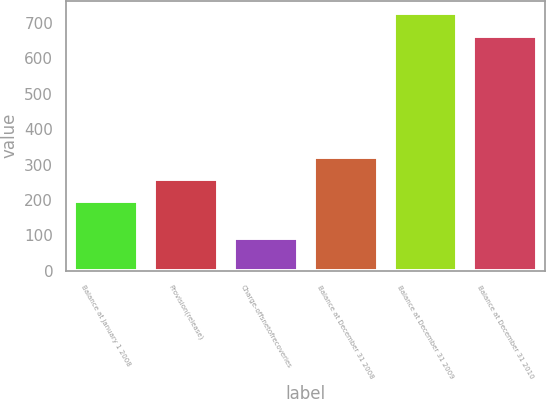Convert chart. <chart><loc_0><loc_0><loc_500><loc_500><bar_chart><fcel>Balance at January 1 2008<fcel>Provision(release)<fcel>Charge-offsnetofrecoveries<fcel>Balance at December 31 2008<fcel>Balance at December 31 2009<fcel>Balance at December 31 2010<nl><fcel>197<fcel>259.8<fcel>93<fcel>322.6<fcel>726.8<fcel>664<nl></chart> 